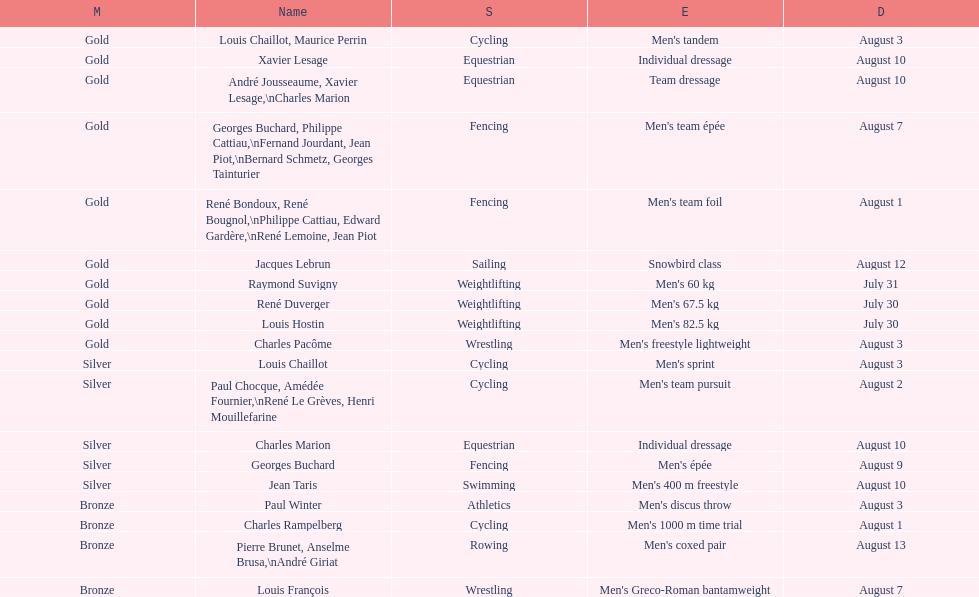Which event won the most medals? Cycling. 